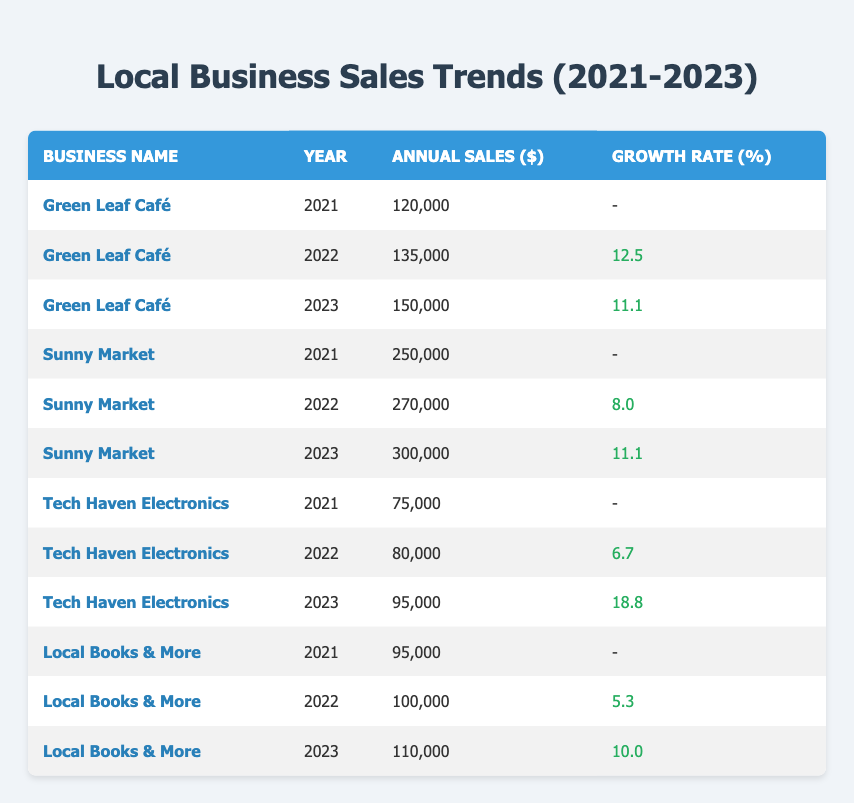What was the annual sales of Green Leaf Café in 2022? According to the table, the annual sales of Green Leaf Café in 2022 is listed as 135,000.
Answer: 135000 Which business had the highest annual sales in 2023? To find the highest annual sales in 2023, we compare the sales figures for all businesses for that year: Green Leaf Café (150,000), Sunny Market (300,000), Tech Haven Electronics (95,000), and Local Books & More (110,000). The highest sales are from Sunny Market at 300,000.
Answer: 300000 What was the average growth rate for Local Books & More over the three years? The growth rates for Local Books & More are: 5.3% in 2022 and 10.0% in 2023. The 2021 rate is not applicable (N/A). To find the average, we sum the available growth rates: (5.3 + 10.0) = 15.3. Then, we divide by 2 (the number of years with growth rates): 15.3 / 2 = 7.65%.
Answer: 7.65 Did Tech Haven Electronics see a growth in sales every year? We check the sales figures: in 2021, sales were 75,000, which increased to 80,000 in 2022, and then further increased to 95,000 in 2023. Since sales went up each year, the answer is yes.
Answer: Yes What was the percentage increase in annual sales for Sunny Market from 2022 to 2023? The annual sales for Sunny Market in 2022 were 270,000 and in 2023, it was 300,000. We calculate the increase: 300,000 - 270,000 = 30,000. To find the percentage increase, we divide the increase by the original amount: (30,000 / 270,000) * 100 = approximately 11.11%.
Answer: 11.11 